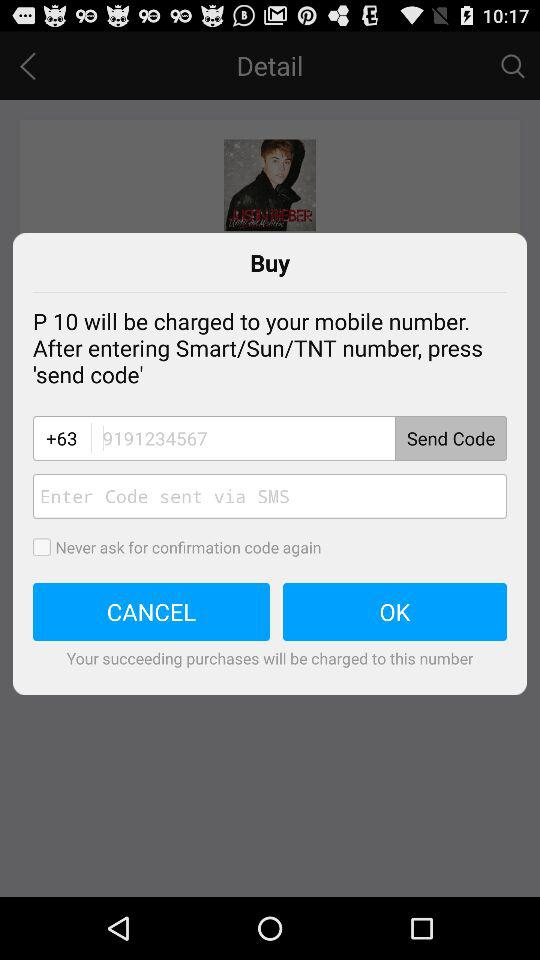How much money will be charged to the mobile number?
When the provided information is insufficient, respond with <no answer>. <no answer> 